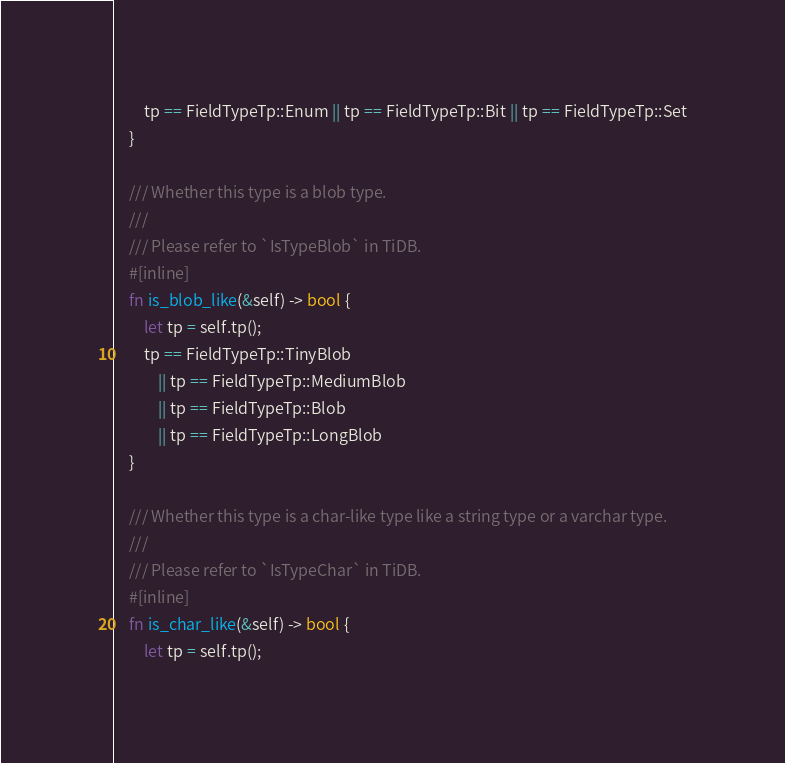<code> <loc_0><loc_0><loc_500><loc_500><_Rust_>        tp == FieldTypeTp::Enum || tp == FieldTypeTp::Bit || tp == FieldTypeTp::Set
    }

    /// Whether this type is a blob type.
    ///
    /// Please refer to `IsTypeBlob` in TiDB.
    #[inline]
    fn is_blob_like(&self) -> bool {
        let tp = self.tp();
        tp == FieldTypeTp::TinyBlob
            || tp == FieldTypeTp::MediumBlob
            || tp == FieldTypeTp::Blob
            || tp == FieldTypeTp::LongBlob
    }

    /// Whether this type is a char-like type like a string type or a varchar type.
    ///
    /// Please refer to `IsTypeChar` in TiDB.
    #[inline]
    fn is_char_like(&self) -> bool {
        let tp = self.tp();</code> 